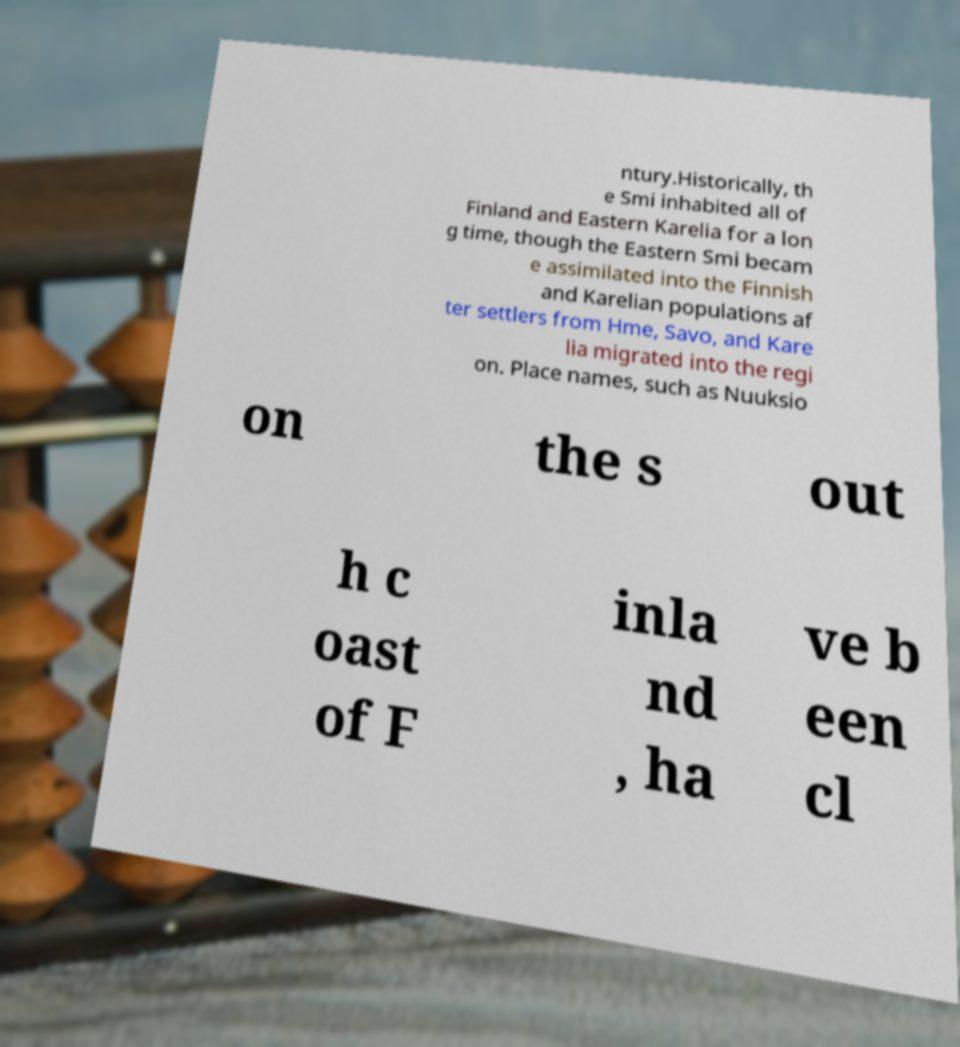Please identify and transcribe the text found in this image. ntury.Historically, th e Smi inhabited all of Finland and Eastern Karelia for a lon g time, though the Eastern Smi becam e assimilated into the Finnish and Karelian populations af ter settlers from Hme, Savo, and Kare lia migrated into the regi on. Place names, such as Nuuksio on the s out h c oast of F inla nd , ha ve b een cl 